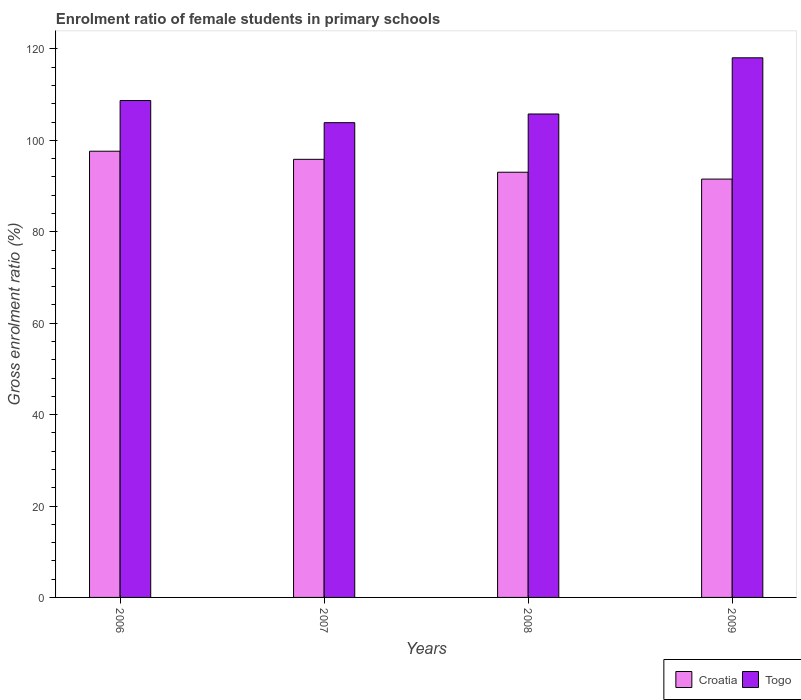How many different coloured bars are there?
Your response must be concise. 2. Are the number of bars per tick equal to the number of legend labels?
Keep it short and to the point. Yes. Are the number of bars on each tick of the X-axis equal?
Your answer should be very brief. Yes. How many bars are there on the 4th tick from the right?
Provide a short and direct response. 2. In how many cases, is the number of bars for a given year not equal to the number of legend labels?
Keep it short and to the point. 0. What is the enrolment ratio of female students in primary schools in Togo in 2008?
Keep it short and to the point. 105.76. Across all years, what is the maximum enrolment ratio of female students in primary schools in Togo?
Provide a succinct answer. 118.05. Across all years, what is the minimum enrolment ratio of female students in primary schools in Togo?
Offer a terse response. 103.86. In which year was the enrolment ratio of female students in primary schools in Togo maximum?
Provide a short and direct response. 2009. What is the total enrolment ratio of female students in primary schools in Croatia in the graph?
Your response must be concise. 378.01. What is the difference between the enrolment ratio of female students in primary schools in Croatia in 2007 and that in 2008?
Give a very brief answer. 2.82. What is the difference between the enrolment ratio of female students in primary schools in Croatia in 2008 and the enrolment ratio of female students in primary schools in Togo in 2009?
Provide a succinct answer. -25.03. What is the average enrolment ratio of female students in primary schools in Togo per year?
Your answer should be very brief. 109.1. In the year 2006, what is the difference between the enrolment ratio of female students in primary schools in Croatia and enrolment ratio of female students in primary schools in Togo?
Keep it short and to the point. -11.09. What is the ratio of the enrolment ratio of female students in primary schools in Croatia in 2006 to that in 2007?
Keep it short and to the point. 1.02. Is the difference between the enrolment ratio of female students in primary schools in Croatia in 2007 and 2008 greater than the difference between the enrolment ratio of female students in primary schools in Togo in 2007 and 2008?
Offer a terse response. Yes. What is the difference between the highest and the second highest enrolment ratio of female students in primary schools in Togo?
Ensure brevity in your answer.  9.35. What is the difference between the highest and the lowest enrolment ratio of female students in primary schools in Togo?
Offer a very short reply. 14.19. In how many years, is the enrolment ratio of female students in primary schools in Togo greater than the average enrolment ratio of female students in primary schools in Togo taken over all years?
Your response must be concise. 1. What does the 1st bar from the left in 2008 represents?
Give a very brief answer. Croatia. What does the 1st bar from the right in 2007 represents?
Provide a short and direct response. Togo. How many bars are there?
Provide a short and direct response. 8. How many years are there in the graph?
Ensure brevity in your answer.  4. What is the difference between two consecutive major ticks on the Y-axis?
Offer a terse response. 20. Does the graph contain any zero values?
Offer a very short reply. No. What is the title of the graph?
Your answer should be compact. Enrolment ratio of female students in primary schools. Does "Channel Islands" appear as one of the legend labels in the graph?
Make the answer very short. No. What is the label or title of the X-axis?
Give a very brief answer. Years. What is the Gross enrolment ratio (%) in Croatia in 2006?
Provide a short and direct response. 97.62. What is the Gross enrolment ratio (%) in Togo in 2006?
Give a very brief answer. 108.71. What is the Gross enrolment ratio (%) in Croatia in 2007?
Ensure brevity in your answer.  95.84. What is the Gross enrolment ratio (%) of Togo in 2007?
Offer a terse response. 103.86. What is the Gross enrolment ratio (%) of Croatia in 2008?
Provide a short and direct response. 93.02. What is the Gross enrolment ratio (%) of Togo in 2008?
Your answer should be compact. 105.76. What is the Gross enrolment ratio (%) of Croatia in 2009?
Your answer should be compact. 91.52. What is the Gross enrolment ratio (%) in Togo in 2009?
Keep it short and to the point. 118.05. Across all years, what is the maximum Gross enrolment ratio (%) of Croatia?
Make the answer very short. 97.62. Across all years, what is the maximum Gross enrolment ratio (%) in Togo?
Make the answer very short. 118.05. Across all years, what is the minimum Gross enrolment ratio (%) in Croatia?
Provide a short and direct response. 91.52. Across all years, what is the minimum Gross enrolment ratio (%) of Togo?
Your response must be concise. 103.86. What is the total Gross enrolment ratio (%) in Croatia in the graph?
Provide a succinct answer. 378.01. What is the total Gross enrolment ratio (%) of Togo in the graph?
Your answer should be very brief. 436.39. What is the difference between the Gross enrolment ratio (%) in Croatia in 2006 and that in 2007?
Keep it short and to the point. 1.77. What is the difference between the Gross enrolment ratio (%) in Togo in 2006 and that in 2007?
Provide a succinct answer. 4.84. What is the difference between the Gross enrolment ratio (%) of Croatia in 2006 and that in 2008?
Your answer should be very brief. 4.6. What is the difference between the Gross enrolment ratio (%) of Togo in 2006 and that in 2008?
Your answer should be compact. 2.94. What is the difference between the Gross enrolment ratio (%) in Croatia in 2006 and that in 2009?
Your answer should be very brief. 6.1. What is the difference between the Gross enrolment ratio (%) of Togo in 2006 and that in 2009?
Make the answer very short. -9.35. What is the difference between the Gross enrolment ratio (%) of Croatia in 2007 and that in 2008?
Offer a very short reply. 2.82. What is the difference between the Gross enrolment ratio (%) in Togo in 2007 and that in 2008?
Make the answer very short. -1.9. What is the difference between the Gross enrolment ratio (%) in Croatia in 2007 and that in 2009?
Your response must be concise. 4.32. What is the difference between the Gross enrolment ratio (%) in Togo in 2007 and that in 2009?
Your answer should be compact. -14.19. What is the difference between the Gross enrolment ratio (%) of Croatia in 2008 and that in 2009?
Keep it short and to the point. 1.5. What is the difference between the Gross enrolment ratio (%) in Togo in 2008 and that in 2009?
Your answer should be very brief. -12.29. What is the difference between the Gross enrolment ratio (%) of Croatia in 2006 and the Gross enrolment ratio (%) of Togo in 2007?
Make the answer very short. -6.24. What is the difference between the Gross enrolment ratio (%) in Croatia in 2006 and the Gross enrolment ratio (%) in Togo in 2008?
Give a very brief answer. -8.14. What is the difference between the Gross enrolment ratio (%) of Croatia in 2006 and the Gross enrolment ratio (%) of Togo in 2009?
Make the answer very short. -20.44. What is the difference between the Gross enrolment ratio (%) in Croatia in 2007 and the Gross enrolment ratio (%) in Togo in 2008?
Your response must be concise. -9.92. What is the difference between the Gross enrolment ratio (%) of Croatia in 2007 and the Gross enrolment ratio (%) of Togo in 2009?
Your answer should be compact. -22.21. What is the difference between the Gross enrolment ratio (%) of Croatia in 2008 and the Gross enrolment ratio (%) of Togo in 2009?
Offer a terse response. -25.03. What is the average Gross enrolment ratio (%) of Croatia per year?
Your response must be concise. 94.5. What is the average Gross enrolment ratio (%) of Togo per year?
Offer a terse response. 109.1. In the year 2006, what is the difference between the Gross enrolment ratio (%) in Croatia and Gross enrolment ratio (%) in Togo?
Provide a short and direct response. -11.09. In the year 2007, what is the difference between the Gross enrolment ratio (%) in Croatia and Gross enrolment ratio (%) in Togo?
Keep it short and to the point. -8.02. In the year 2008, what is the difference between the Gross enrolment ratio (%) of Croatia and Gross enrolment ratio (%) of Togo?
Make the answer very short. -12.74. In the year 2009, what is the difference between the Gross enrolment ratio (%) in Croatia and Gross enrolment ratio (%) in Togo?
Your answer should be very brief. -26.53. What is the ratio of the Gross enrolment ratio (%) of Croatia in 2006 to that in 2007?
Your response must be concise. 1.02. What is the ratio of the Gross enrolment ratio (%) of Togo in 2006 to that in 2007?
Offer a terse response. 1.05. What is the ratio of the Gross enrolment ratio (%) in Croatia in 2006 to that in 2008?
Your answer should be very brief. 1.05. What is the ratio of the Gross enrolment ratio (%) in Togo in 2006 to that in 2008?
Offer a terse response. 1.03. What is the ratio of the Gross enrolment ratio (%) in Croatia in 2006 to that in 2009?
Your answer should be very brief. 1.07. What is the ratio of the Gross enrolment ratio (%) in Togo in 2006 to that in 2009?
Your answer should be compact. 0.92. What is the ratio of the Gross enrolment ratio (%) in Croatia in 2007 to that in 2008?
Give a very brief answer. 1.03. What is the ratio of the Gross enrolment ratio (%) of Togo in 2007 to that in 2008?
Offer a terse response. 0.98. What is the ratio of the Gross enrolment ratio (%) of Croatia in 2007 to that in 2009?
Your answer should be compact. 1.05. What is the ratio of the Gross enrolment ratio (%) of Togo in 2007 to that in 2009?
Provide a short and direct response. 0.88. What is the ratio of the Gross enrolment ratio (%) of Croatia in 2008 to that in 2009?
Your answer should be very brief. 1.02. What is the ratio of the Gross enrolment ratio (%) of Togo in 2008 to that in 2009?
Your answer should be compact. 0.9. What is the difference between the highest and the second highest Gross enrolment ratio (%) of Croatia?
Offer a terse response. 1.77. What is the difference between the highest and the second highest Gross enrolment ratio (%) in Togo?
Make the answer very short. 9.35. What is the difference between the highest and the lowest Gross enrolment ratio (%) in Croatia?
Your answer should be very brief. 6.1. What is the difference between the highest and the lowest Gross enrolment ratio (%) in Togo?
Keep it short and to the point. 14.19. 